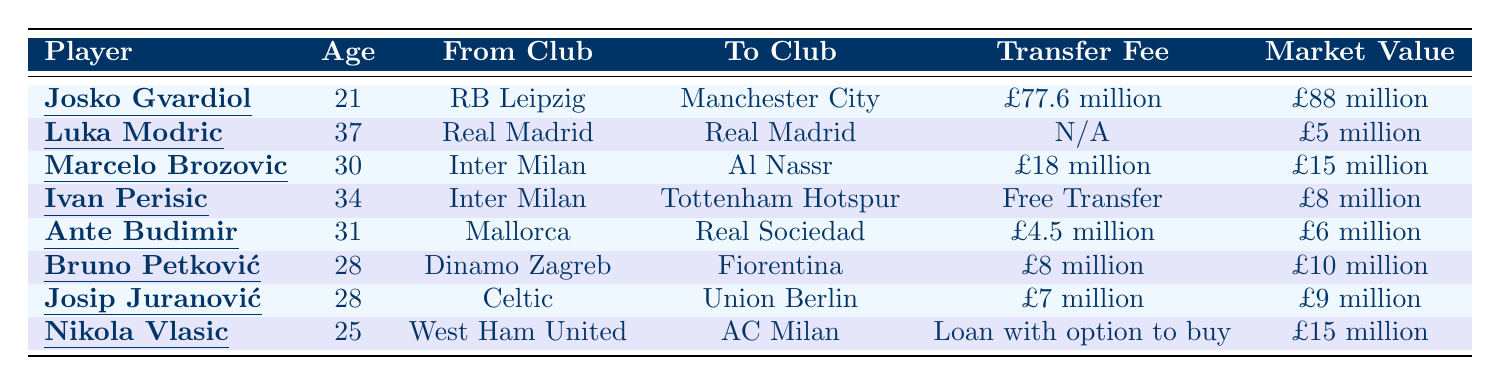What is the transfer fee for Josko Gvardiol? The table states the transfer fee for Josko Gvardiol is listed as £77.6 million.
Answer: £77.6 million How old is Luka Modric? Luka Modric's age, as mentioned in the table, is 37.
Answer: 37 Which clubs did Marcelo Brozovic move between? The table indicates that Marcelo Brozovic moved from Inter Milan to Al Nassr.
Answer: Inter Milan to Al Nassr What is the market value of Ivan Perisic? According to the table, Ivan Perisic's market value is £8 million.
Answer: £8 million How much did Ante Budimir transfer for? The table lists Ante Budimir's transfer fee as £4.5 million.
Answer: £4.5 million Who had the highest market value in 2023? The table shows that Josko Gvardiol has the highest market value at £88 million compared to others.
Answer: £88 million Is Luka Modric's transfer fee listed? The table indicates that Luka Modric's transfer fee is N/A, meaning it is not applicable.
Answer: No Which player transferred on a free transfer? The table indicates that Ivan Perisic transferred on a free transfer.
Answer: Ivan Perisic What is the sum of the market values of Bruno Petković and Nikola Vlasic? Bruno Petković's market value is £10 million and Nikola Vlasic's is £15 million; adding these gives £10 million + £15 million = £25 million.
Answer: £25 million Which player was transferred for the least amount? Ante Budimir was transferred for £4.5 million, which is the lowest compared to all others listed.
Answer: Ante Budimir What is the average age of the players listed in the table? The ages of the players are 21, 37, 30, 34, 31, 28, 28, and 25. The sum is  21 + 37 + 30 + 34 + 31 + 28 + 28 + 25 =  304. There are 8 players, so the average age is 304 / 8 = 38.
Answer: 38 Did any Croatian player transfer within the same club? The table shows Luka Modric transferred from Real Madrid to Real Madrid, indicating he remained at the same club.
Answer: Yes What is the difference between the highest and lowest market values among the players? The highest market value is £88 million for Josko Gvardiol and the lowest is £5 million for Luka Modric. The difference is £88 million - £5 million = £83 million.
Answer: £83 million 